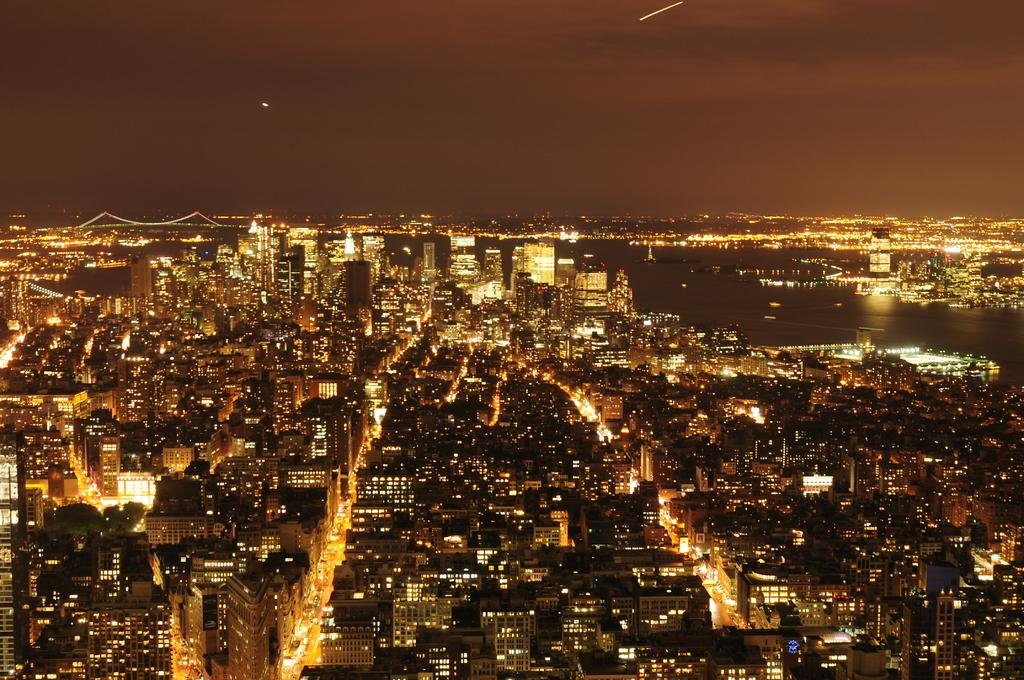What type of structures are illuminated in the image? There are many buildings with lights in the image. What natural elements can be seen in the image? There are trees and water visible in the image. What architectural feature is present in the back of the image? There is a bridge in the back of the image. What part of the natural environment is visible in the image? The sky is visible in the image. What type of silk is draped over the trees in the image? There is no silk present in the image; it features buildings, trees, water, a bridge, and the sky. How does the knowledge of the image contribute to the understanding of the soda industry? The image does not contain any information related to the soda industry, so it cannot contribute to the understanding of that topic. 